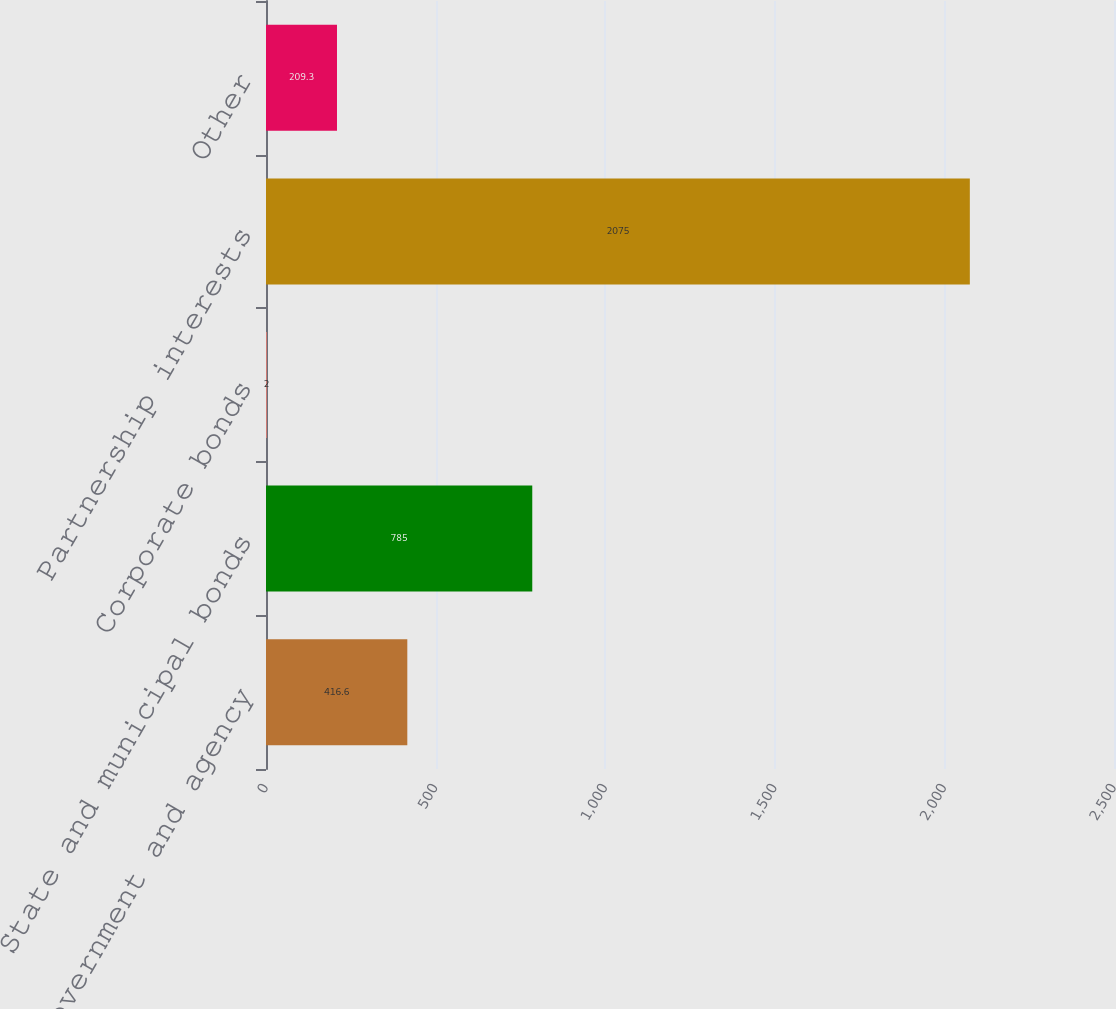<chart> <loc_0><loc_0><loc_500><loc_500><bar_chart><fcel>US government and agency<fcel>State and municipal bonds<fcel>Corporate bonds<fcel>Partnership interests<fcel>Other<nl><fcel>416.6<fcel>785<fcel>2<fcel>2075<fcel>209.3<nl></chart> 